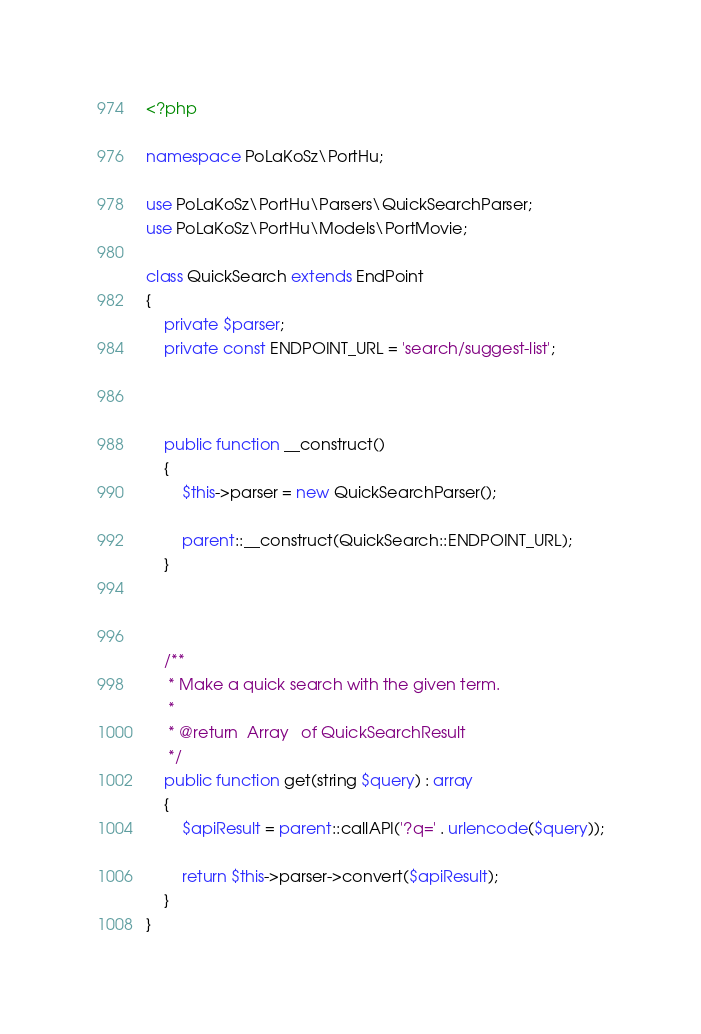Convert code to text. <code><loc_0><loc_0><loc_500><loc_500><_PHP_><?php

namespace PoLaKoSz\PortHu;

use PoLaKoSz\PortHu\Parsers\QuickSearchParser;
use PoLaKoSz\PortHu\Models\PortMovie;

class QuickSearch extends EndPoint
{
    private $parser;
    private const ENDPOINT_URL = 'search/suggest-list';



    public function __construct()
    {
        $this->parser = new QuickSearchParser();

        parent::__construct(QuickSearch::ENDPOINT_URL);
    }



    /**
     * Make a quick search with the given term.
     *
     * @return  Array   of QuickSearchResult
     */
    public function get(string $query) : array
    {
        $apiResult = parent::callAPI('?q=' . urlencode($query));

        return $this->parser->convert($apiResult);
    }
}
</code> 